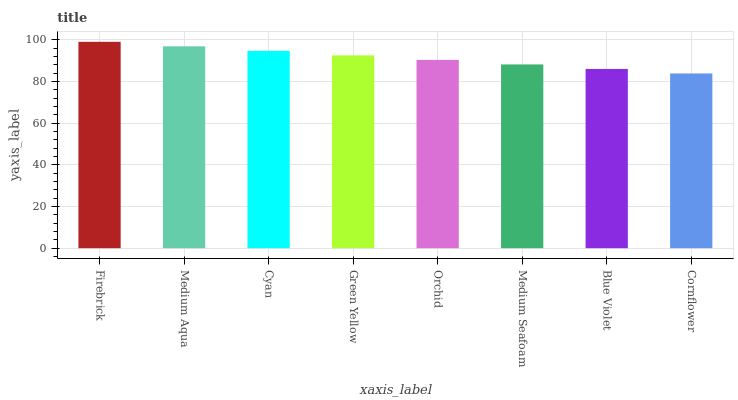Is Cornflower the minimum?
Answer yes or no. Yes. Is Firebrick the maximum?
Answer yes or no. Yes. Is Medium Aqua the minimum?
Answer yes or no. No. Is Medium Aqua the maximum?
Answer yes or no. No. Is Firebrick greater than Medium Aqua?
Answer yes or no. Yes. Is Medium Aqua less than Firebrick?
Answer yes or no. Yes. Is Medium Aqua greater than Firebrick?
Answer yes or no. No. Is Firebrick less than Medium Aqua?
Answer yes or no. No. Is Green Yellow the high median?
Answer yes or no. Yes. Is Orchid the low median?
Answer yes or no. Yes. Is Blue Violet the high median?
Answer yes or no. No. Is Green Yellow the low median?
Answer yes or no. No. 